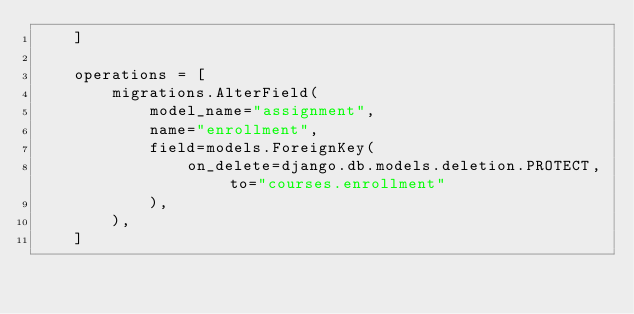Convert code to text. <code><loc_0><loc_0><loc_500><loc_500><_Python_>    ]

    operations = [
        migrations.AlterField(
            model_name="assignment",
            name="enrollment",
            field=models.ForeignKey(
                on_delete=django.db.models.deletion.PROTECT, to="courses.enrollment"
            ),
        ),
    ]
</code> 